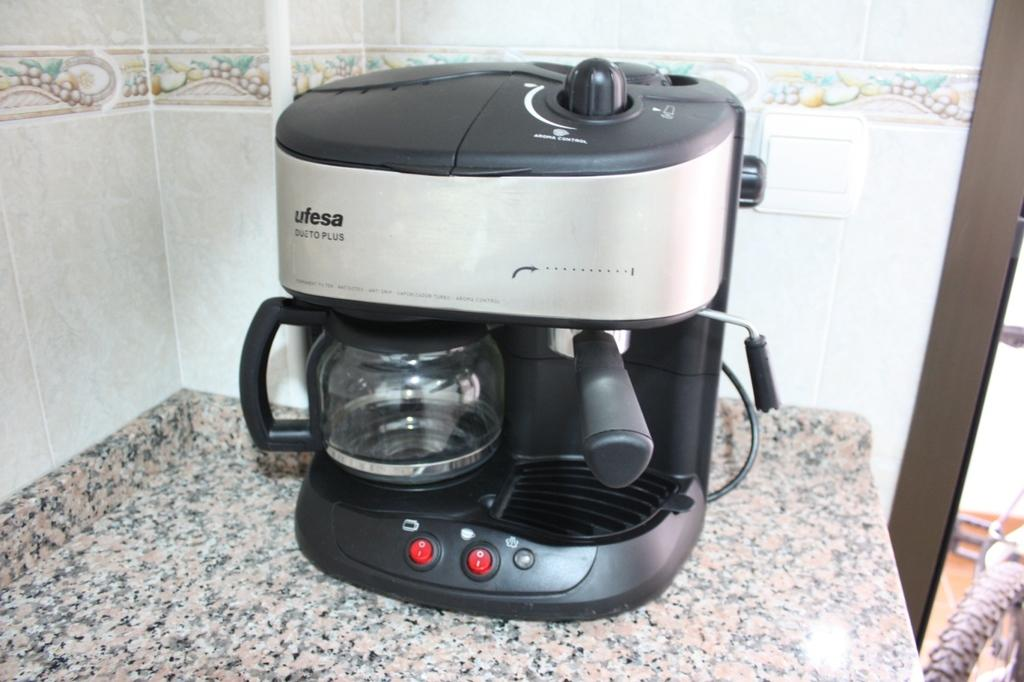<image>
Write a terse but informative summary of the picture. A ufesa Dueto Plus coffee maker sits on a counter with tiles featuring fruit on the wall behind it. 